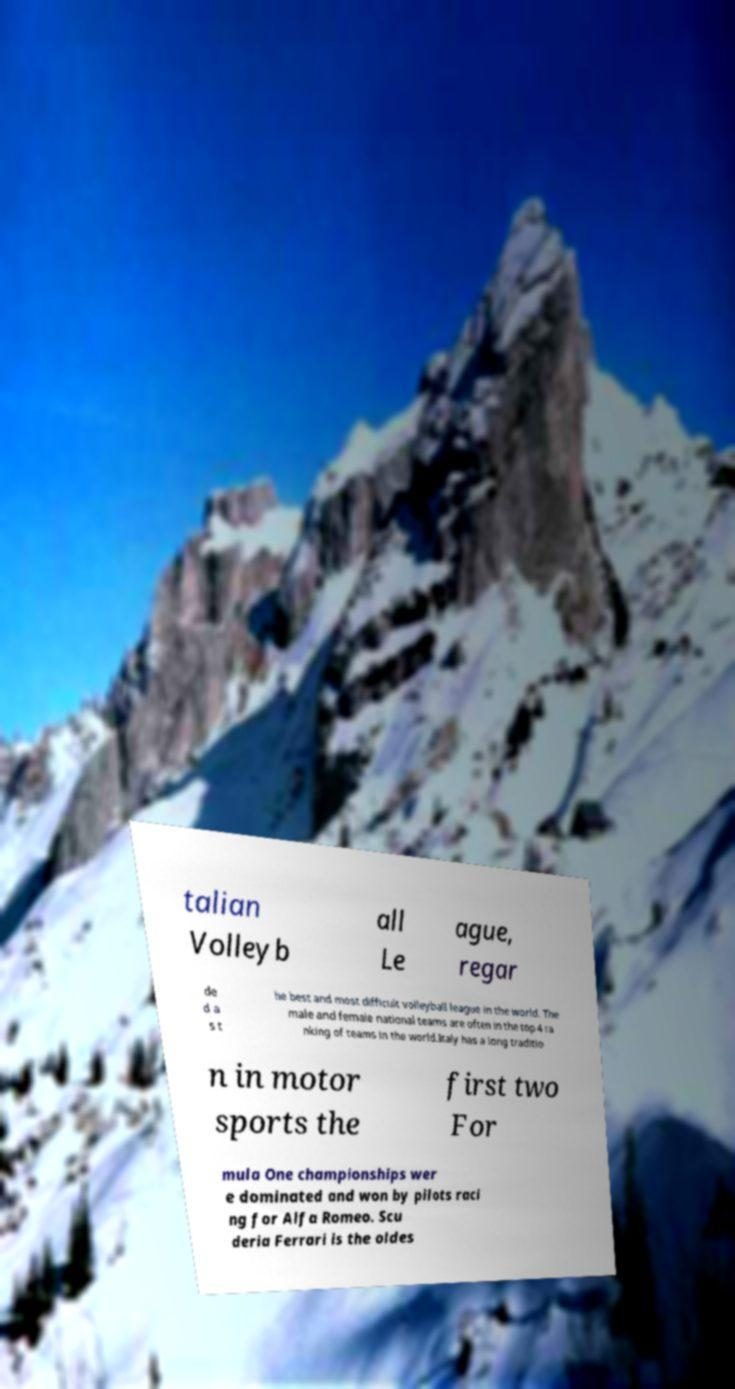Please identify and transcribe the text found in this image. talian Volleyb all Le ague, regar de d a s t he best and most difficult volleyball league in the world. The male and female national teams are often in the top 4 ra nking of teams in the world.Italy has a long traditio n in motor sports the first two For mula One championships wer e dominated and won by pilots raci ng for Alfa Romeo. Scu deria Ferrari is the oldes 